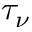<formula> <loc_0><loc_0><loc_500><loc_500>\tau _ { \nu }</formula> 